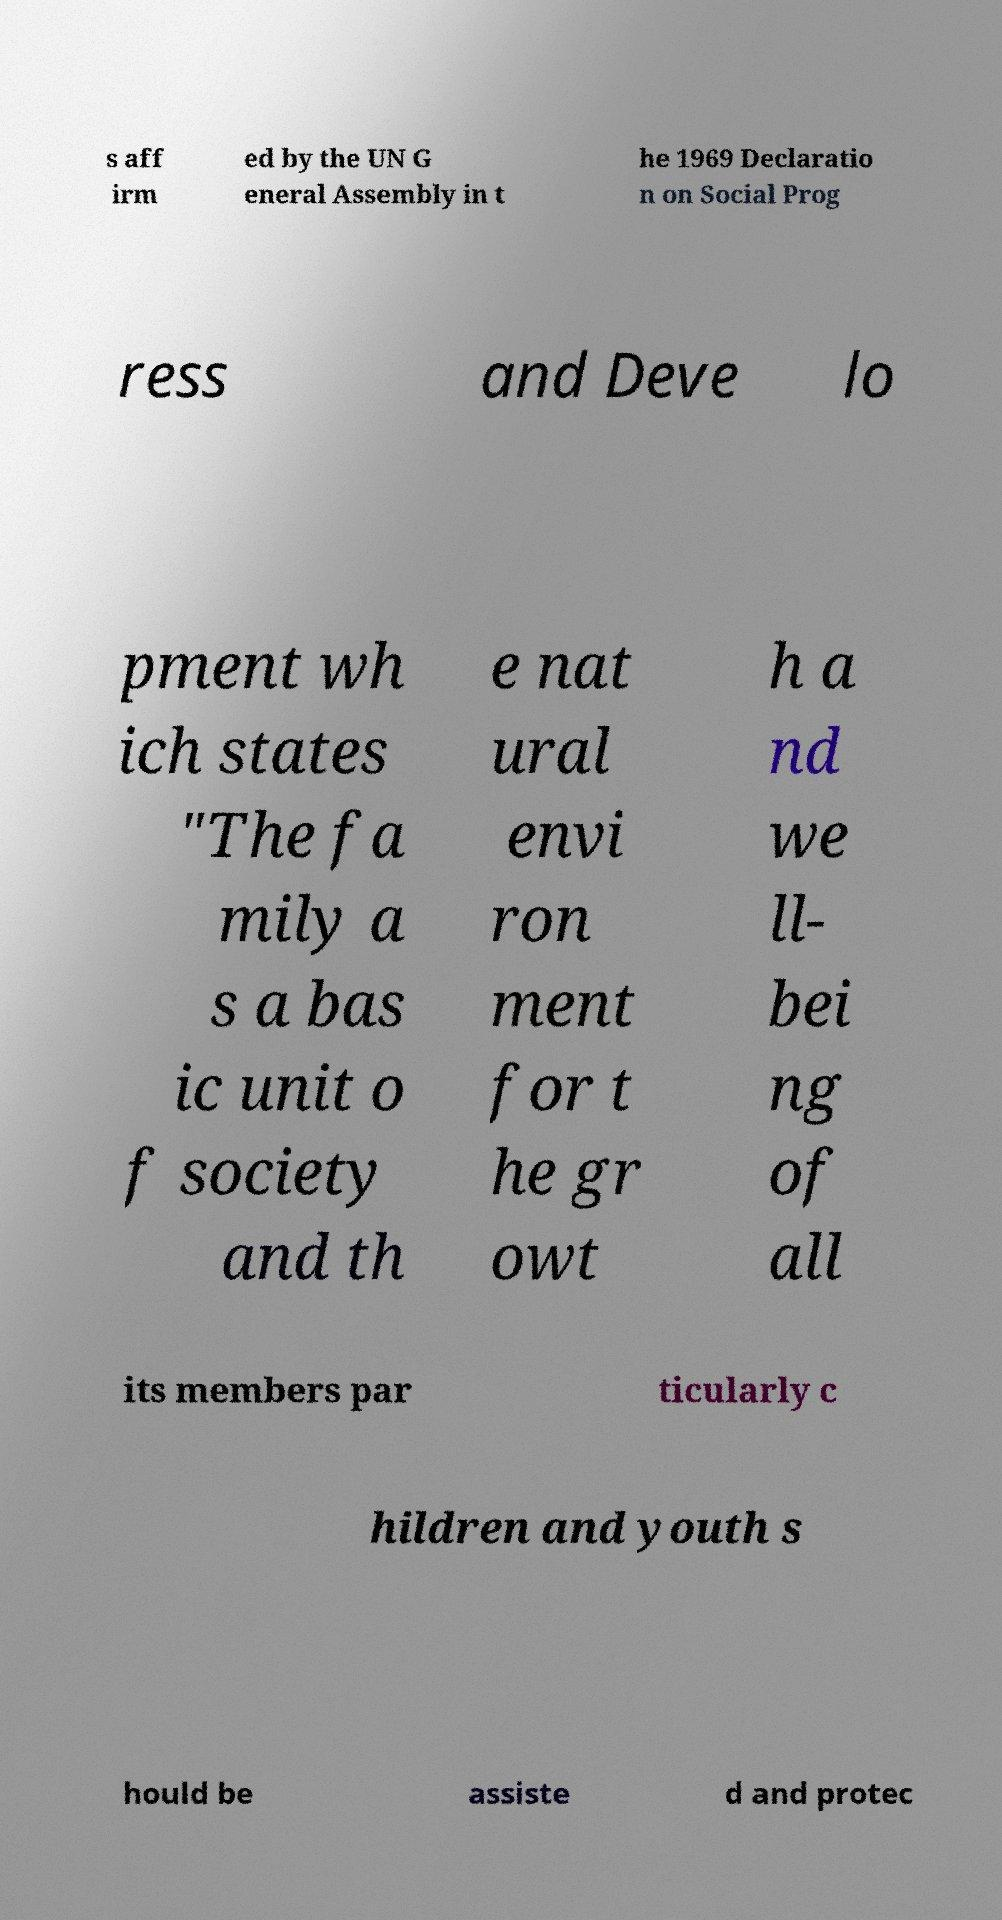Can you read and provide the text displayed in the image?This photo seems to have some interesting text. Can you extract and type it out for me? s aff irm ed by the UN G eneral Assembly in t he 1969 Declaratio n on Social Prog ress and Deve lo pment wh ich states "The fa mily a s a bas ic unit o f society and th e nat ural envi ron ment for t he gr owt h a nd we ll- bei ng of all its members par ticularly c hildren and youth s hould be assiste d and protec 